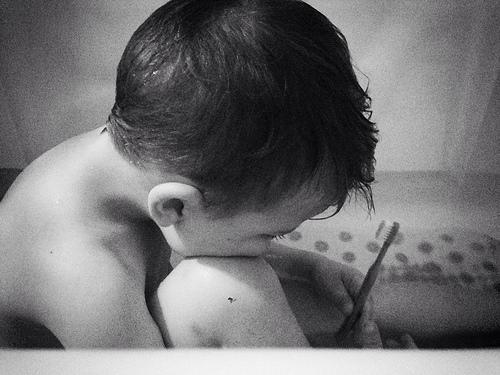Elaborate on the people and objects in the image and describe the ongoing activity. In the image, there's a boy with wet, combed hair sitting in a bathtub, resting his head on his knee, and curiously observing the toothbrush he's holding. In the photo, what is the key visual and what action is taking place? The central visual is a naked boy in a bathroom with wet hair, holding a toothbrush and resting his head on his knee. Describe the appearance and actions of the person in this image. The boy, with short brown wet hair, is sitting in a bathtub with his head resting on his knee and holding a toothbrush in his hands. What is the main subject in the image and what are they doing in simple terms? A child in a bathtub is looking at a toothbrush while resting his head on his knee. Mention what's most apparent about the individual and their actions in the snapshot. The wet-haired boy sitting in the bathtub, examining his toothbrush and resting his head on his knee, is quite noticeable. Discuss the most significant aspect of the image and the action occurring. The most important element in the image is a naked boy with wet hair in a bathroom, who is holding a toothbrush and placing his head on his knee. Summarize the scene captured in the picture using simple language. There is a little boy in a bath with a toothbrush, looking at it while resting his head on his knee. Provide a brief description of the primary focus of the image. A young boy with wet hair is resting his head on his knee in a bathtub while holding a toothbrush in his hand. Offer a casual description of the image's main subject and their action. There's a kid in the bath, just chilling with his head on his knee and holding his toothbrush, looking at it. Using informal language, explain what you see in the image. A young kid is chilling in a bathtub, checking out the toothbrush he's holding, while his head is leaning on his knee. 